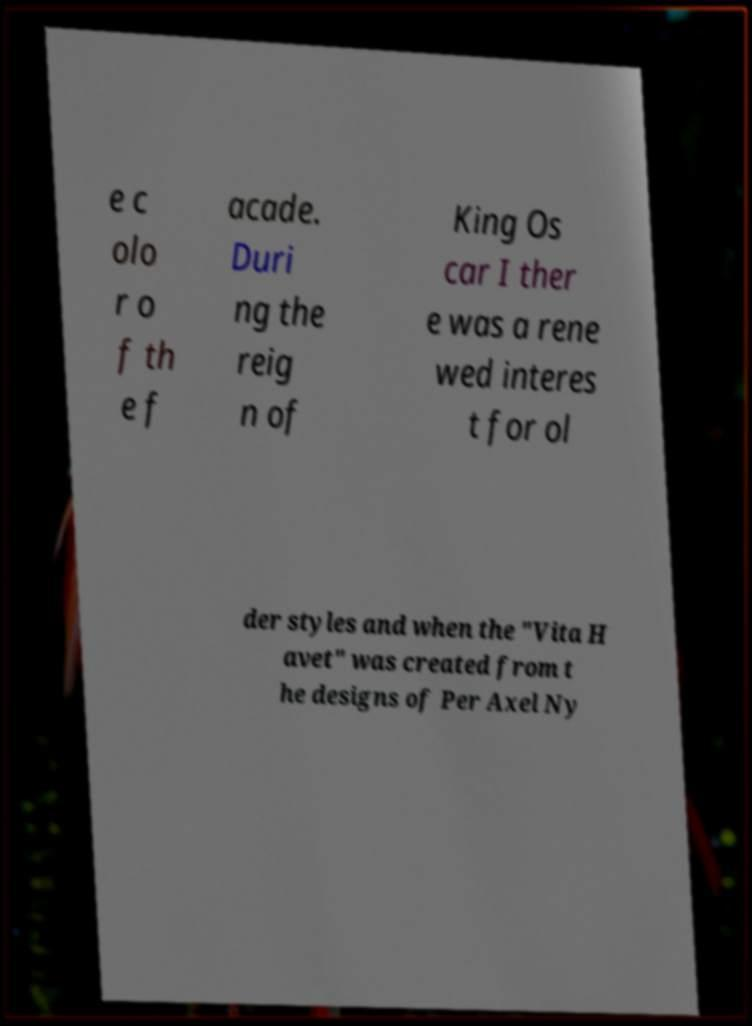There's text embedded in this image that I need extracted. Can you transcribe it verbatim? e c olo r o f th e f acade. Duri ng the reig n of King Os car I ther e was a rene wed interes t for ol der styles and when the "Vita H avet" was created from t he designs of Per Axel Ny 